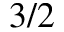<formula> <loc_0><loc_0><loc_500><loc_500>3 / 2</formula> 